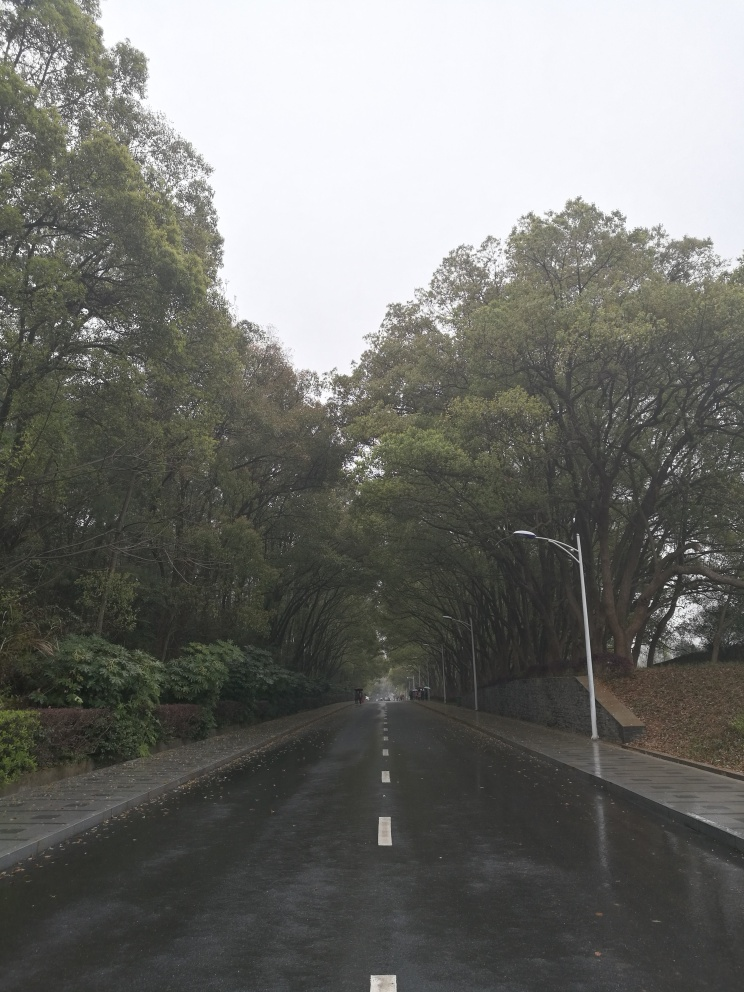Is the overall quality of this photo below average?
 False 